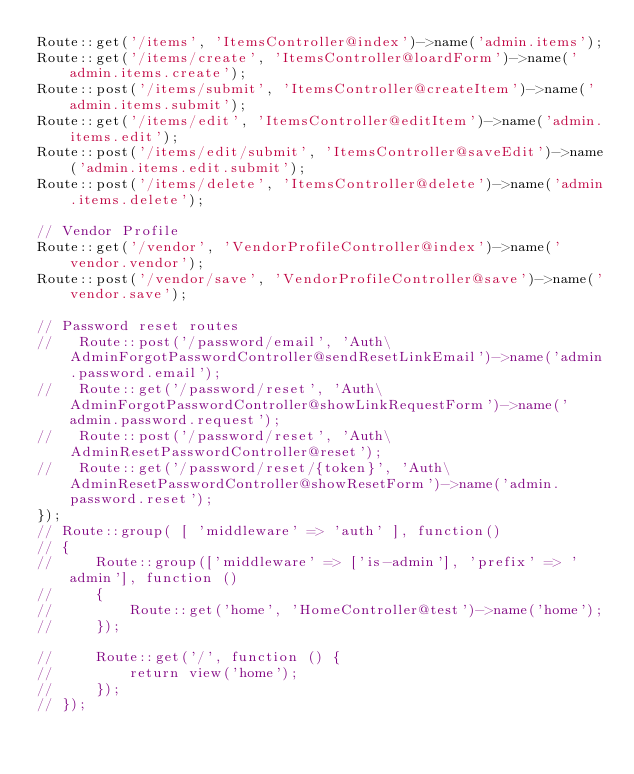Convert code to text. <code><loc_0><loc_0><loc_500><loc_500><_PHP_>Route::get('/items', 'ItemsController@index')->name('admin.items');
Route::get('/items/create', 'ItemsController@loardForm')->name('admin.items.create');
Route::post('/items/submit', 'ItemsController@createItem')->name('admin.items.submit');
Route::get('/items/edit', 'ItemsController@editItem')->name('admin.items.edit');
Route::post('/items/edit/submit', 'ItemsController@saveEdit')->name('admin.items.edit.submit');
Route::post('/items/delete', 'ItemsController@delete')->name('admin.items.delete');

// Vendor Profile
Route::get('/vendor', 'VendorProfileController@index')->name('vendor.vendor');
Route::post('/vendor/save', 'VendorProfileController@save')->name('vendor.save');

// Password reset routes
//   Route::post('/password/email', 'Auth\AdminForgotPasswordController@sendResetLinkEmail')->name('admin.password.email');
//   Route::get('/password/reset', 'Auth\AdminForgotPasswordController@showLinkRequestForm')->name('admin.password.request');
//   Route::post('/password/reset', 'Auth\AdminResetPasswordController@reset');
//   Route::get('/password/reset/{token}', 'Auth\AdminResetPasswordController@showResetForm')->name('admin.password.reset');
});
// Route::group( [ 'middleware' => 'auth' ], function()
// {
//     Route::group(['middleware' => ['is-admin'], 'prefix' => 'admin'], function () 
//     {
//         Route::get('home', 'HomeController@test')->name('home');   
//     });

//     Route::get('/', function () {
//         return view('home');
//     });
// });</code> 